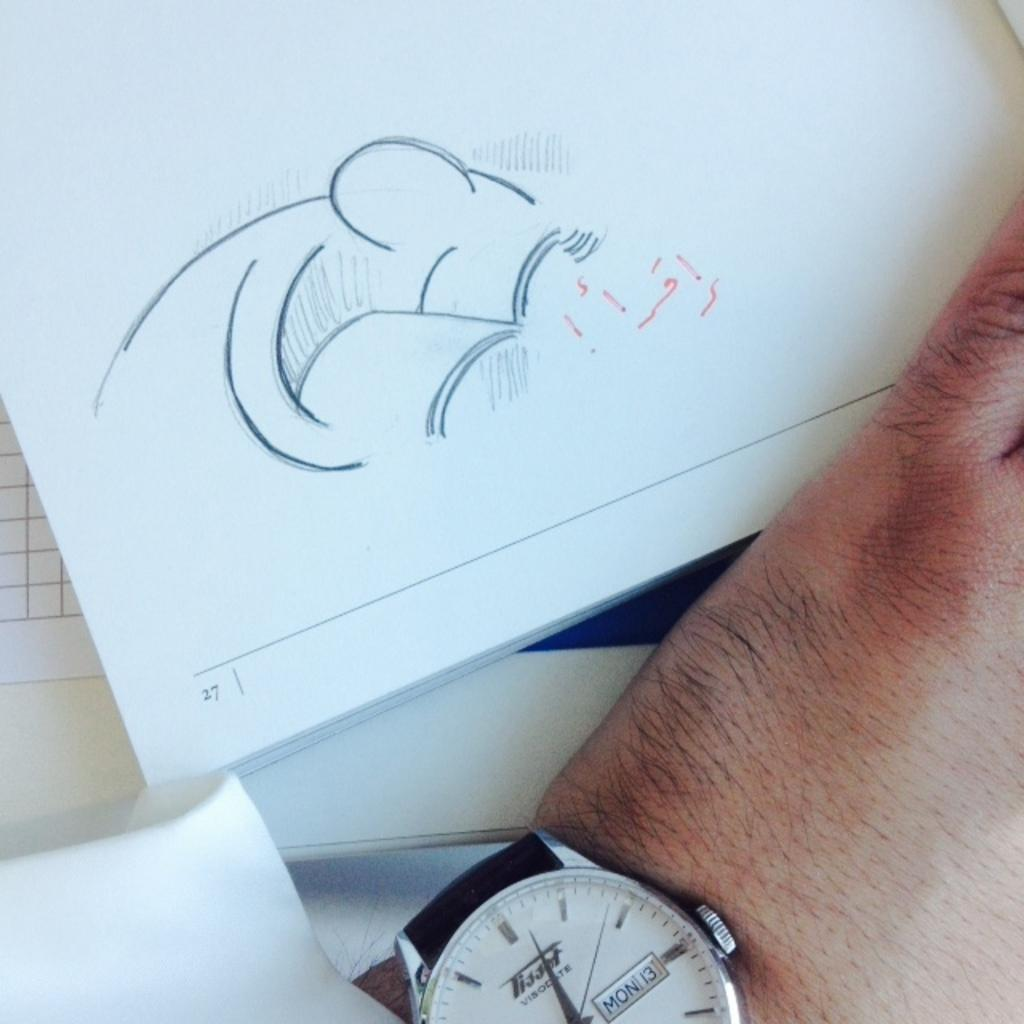<image>
Offer a succinct explanation of the picture presented. A person with a sketch on page 27 and showing part of the hand and watch with date Mon 13 